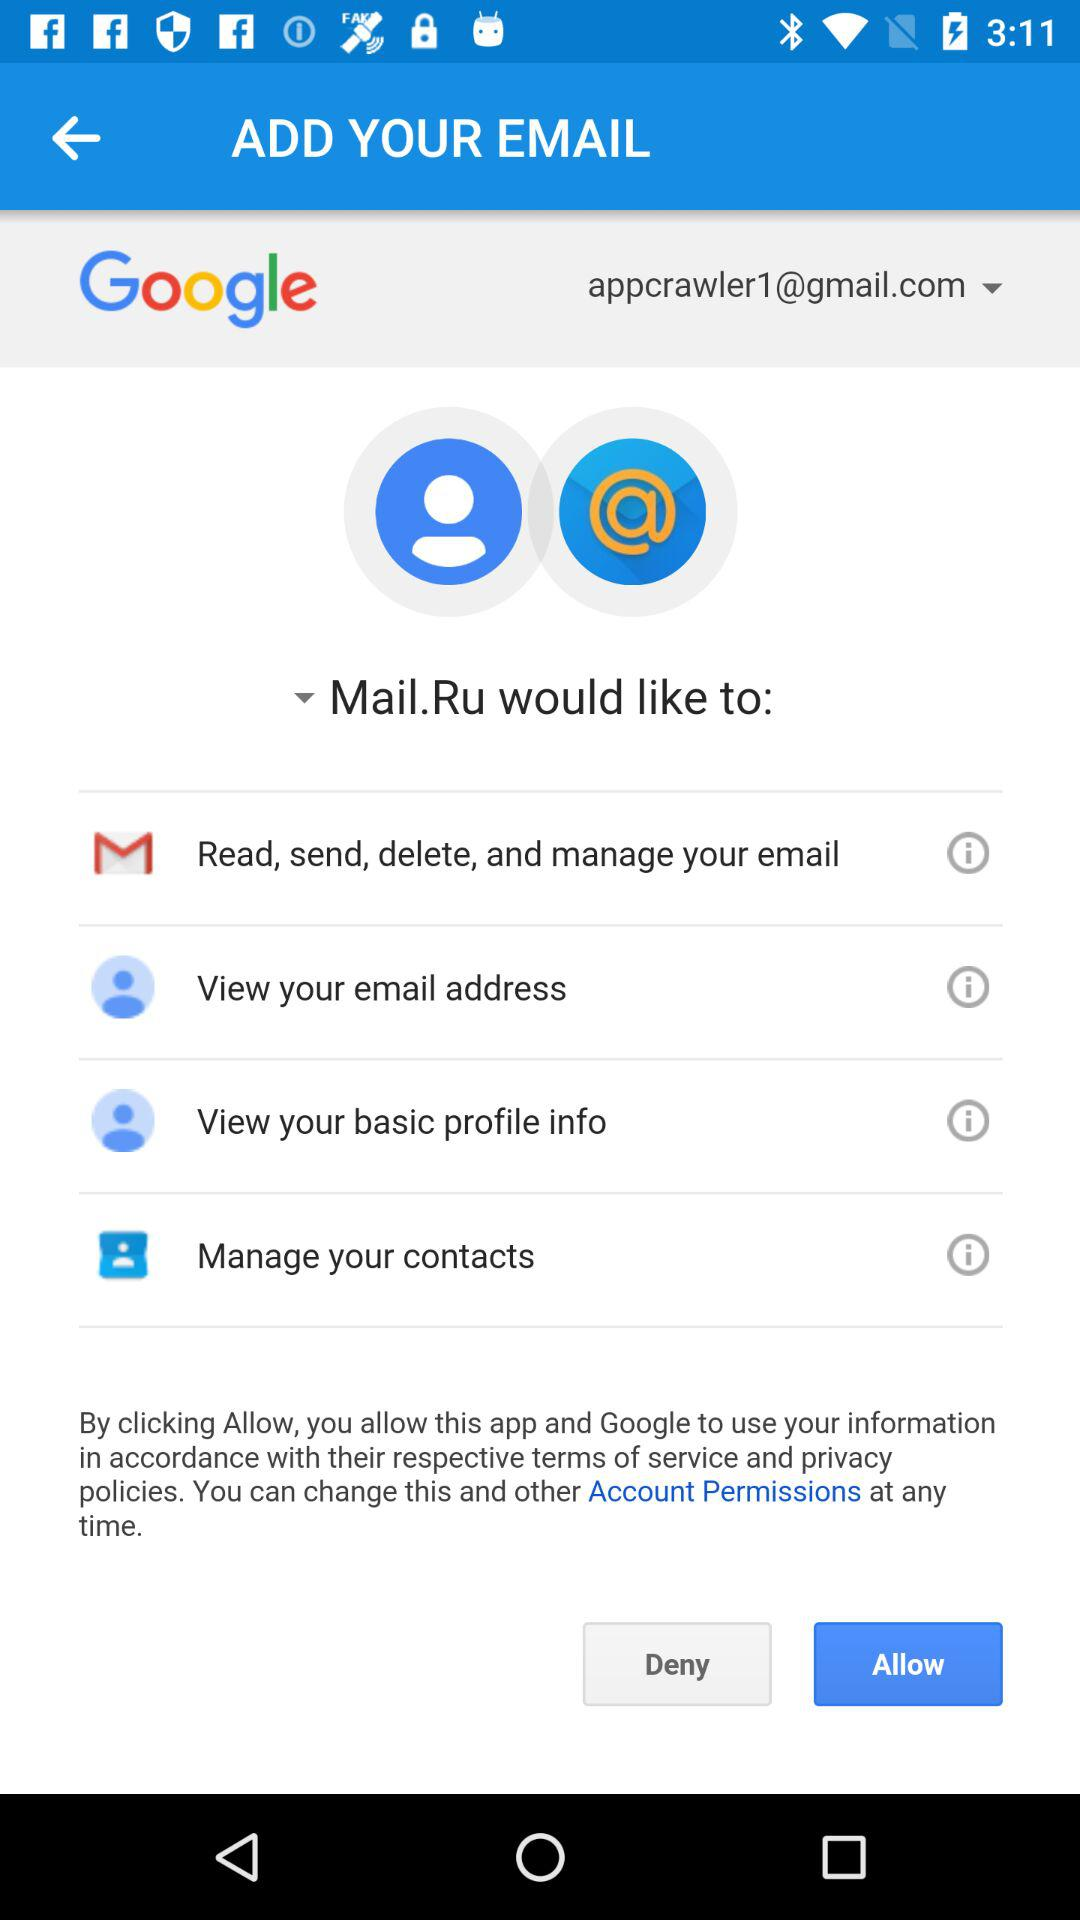How many permissions does the app ask for?
Answer the question using a single word or phrase. 4 